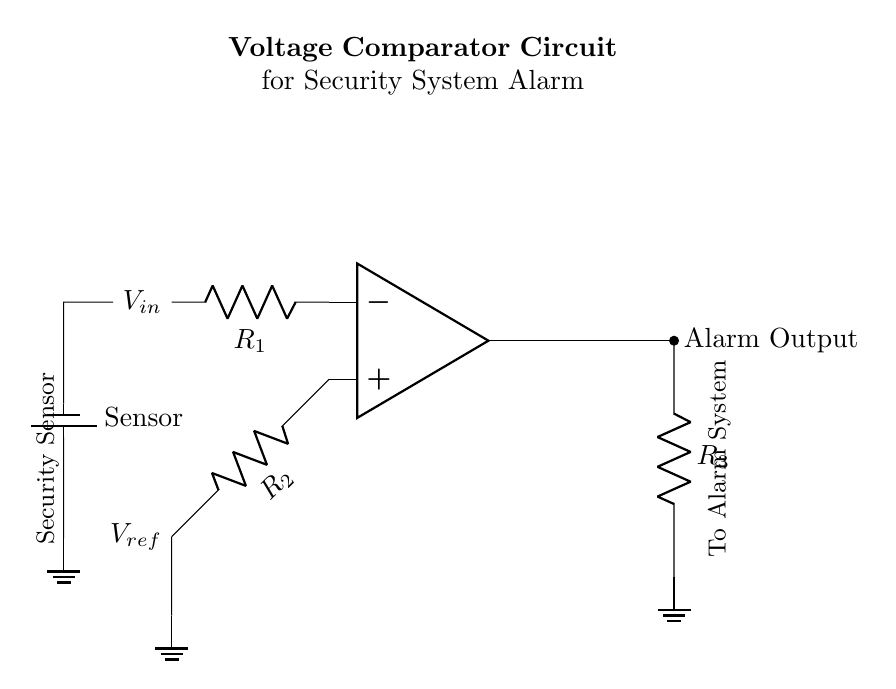What is the role of the operational amplifier in this circuit? The operational amplifier compares the input voltage (V_in) to the reference voltage (V_ref) and outputs a signal based on their relationship. If V_in is greater than V_ref, the output is activated to trigger the alarm.
Answer: comparator What component provides the reference voltage? The circuit diagram shows a resistor labeled R_2 connected to the reference voltage (V_ref), indicating that it provides the necessary reference voltage for comparison with V_in.
Answer: R_2 Which component connects the output of the op-amp to the alarm system? The output of the operational amplifier is connected to the alarm system through a resistor labeled R_3. This resistor forms part of the output path for the alarm signal.
Answer: R_3 What happens when the input voltage exceeds the reference voltage? When V_in exceeds V_ref, the operational amplifier outputs a signal to trigger the alarm, indicating a detection event by the security sensor. This logic is central to the functioning of the comparator in an alarm system.
Answer: Trigger alarm What type of sensor is used in this circuit? The circuit diagram labels a component connected to V_in as a "Sensor," indicating that it detects environmental changes and is part of the security system’s functioning.
Answer: Security sensor What is the purpose of the grounding in this circuit? Grounding provides a common reference point for the circuit, ensuring stable operation and a defined voltage level for both the reference voltage and the return path for alarm output. It helps to prevent false triggering and ensures reliability.
Answer: Stability 